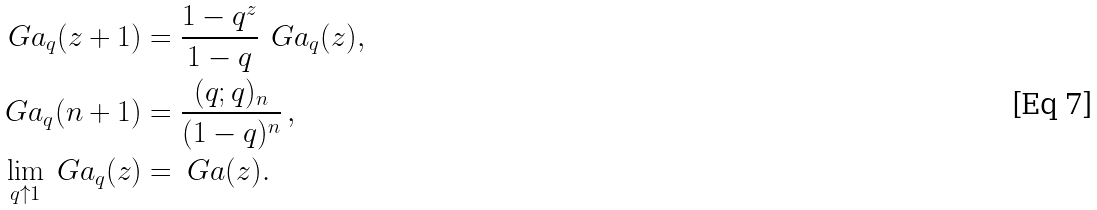<formula> <loc_0><loc_0><loc_500><loc_500>\ G a _ { q } ( z + 1 ) & = \frac { 1 - q ^ { z } } { 1 - q } \, \ G a _ { q } ( z ) , \\ \ G a _ { q } ( n + 1 ) & = \frac { ( q ; q ) _ { n } } { ( 1 - q ) ^ { n } } \, , \\ \lim _ { q \uparrow 1 } \ G a _ { q } ( z ) & = \ G a ( z ) .</formula> 